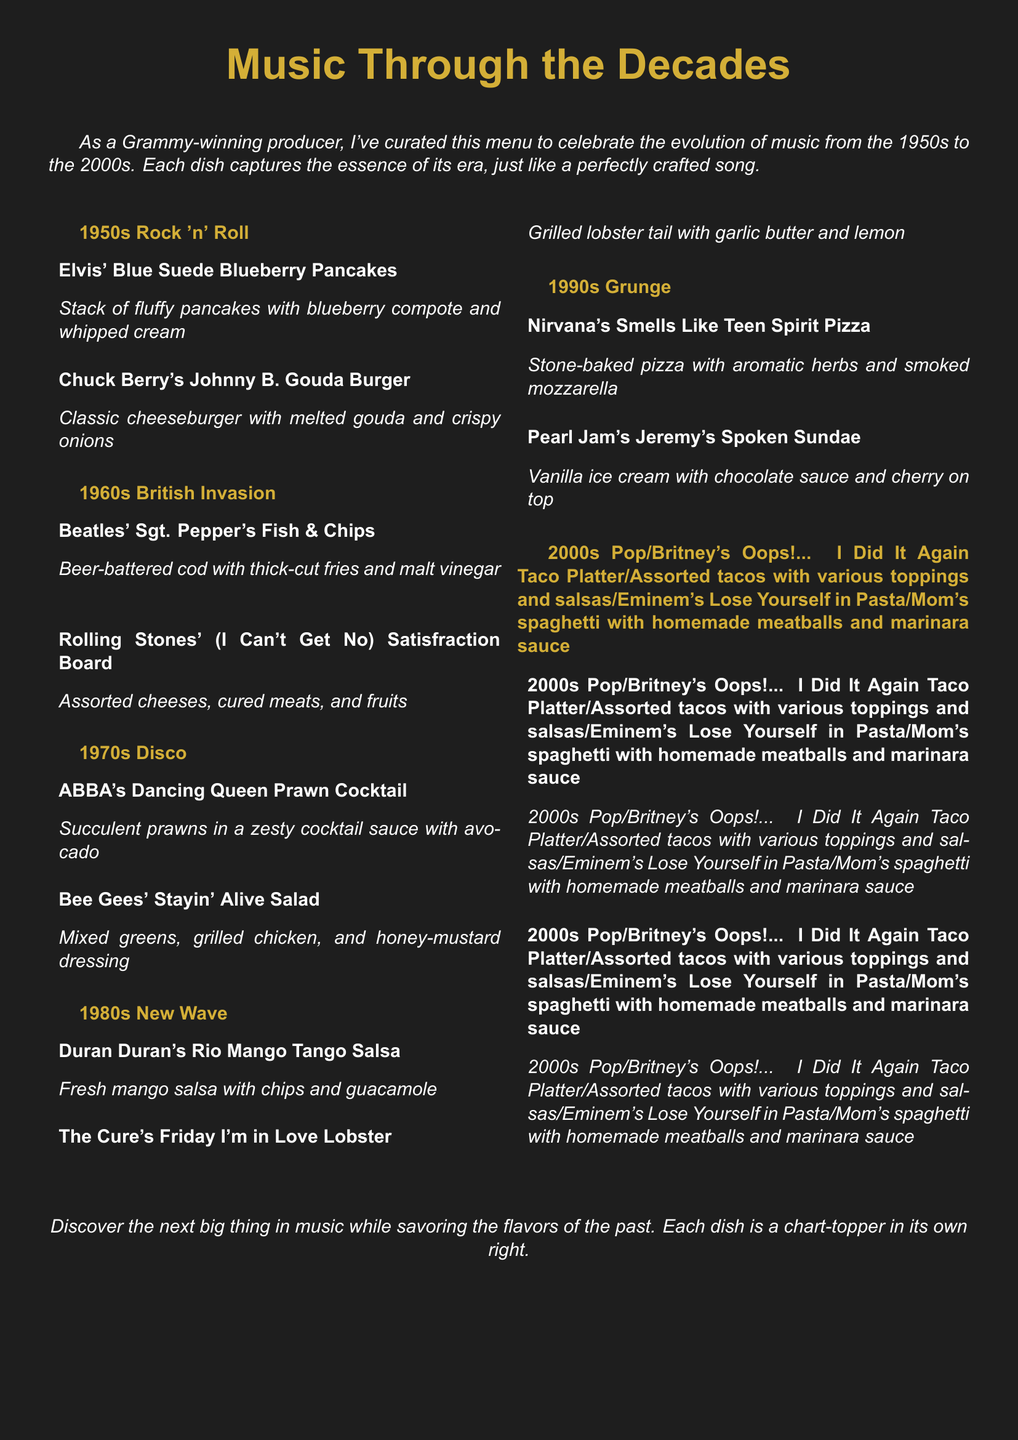What decade features Elvis' Blue Suede Blueberry Pancakes? The decade for this dish is the 1950s, as listed under 1950s Rock 'n' Roll.
Answer: 1950s What is the main ingredient of the Rolling Stones' (I Can't Get No) Satisfraction Board? The board features assorted cheeses, cured meats, and fruits as its main components, characterizing the 1960s.
Answer: Assorted cheeses, cured meats, and fruits Which dish represents 1970s Disco? The dish representing this era is ABBA's Dancing Queen Prawn Cocktail, as found under that category.
Answer: ABBA's Dancing Queen Prawn Cocktail What type of cuisine is featured in Britney's Oops!... I Did It Again Taco Platter? This dish features a variety of tacos with various toppings and salsas, representative of the 2000s Pop section.
Answer: Assorted tacos with various toppings and salsas How many dishes are listed for each decade? Each decade features two dishes, one for a singer and one for a group.
Answer: Two Which dish includes a garlic butter preparation? The dish with garlic butter is The Cure's Friday I'm in Love Lobster, found under the 1980s New Wave section.
Answer: The Cure's Friday I'm in Love Lobster What is the theme of the menu presented in the document? The theme is a culinary tribute to the evolution of music, spanning from the 1950s to the 2000s.
Answer: Music Through the Decades What is the dish that comes with chocolate sauce? The dish with chocolate sauce is Pearl Jam's Jeremy's Spoken Sundae in the 1990s Grunge section.
Answer: Pearl Jam's Jeremy's Spoken Sundae 